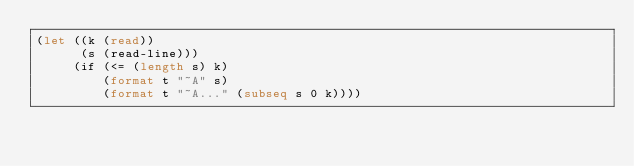Convert code to text. <code><loc_0><loc_0><loc_500><loc_500><_Lisp_>(let ((k (read))
      (s (read-line)))
     (if (<= (length s) k)
         (format t "~A" s)
         (format t "~A..." (subseq s 0 k))))</code> 